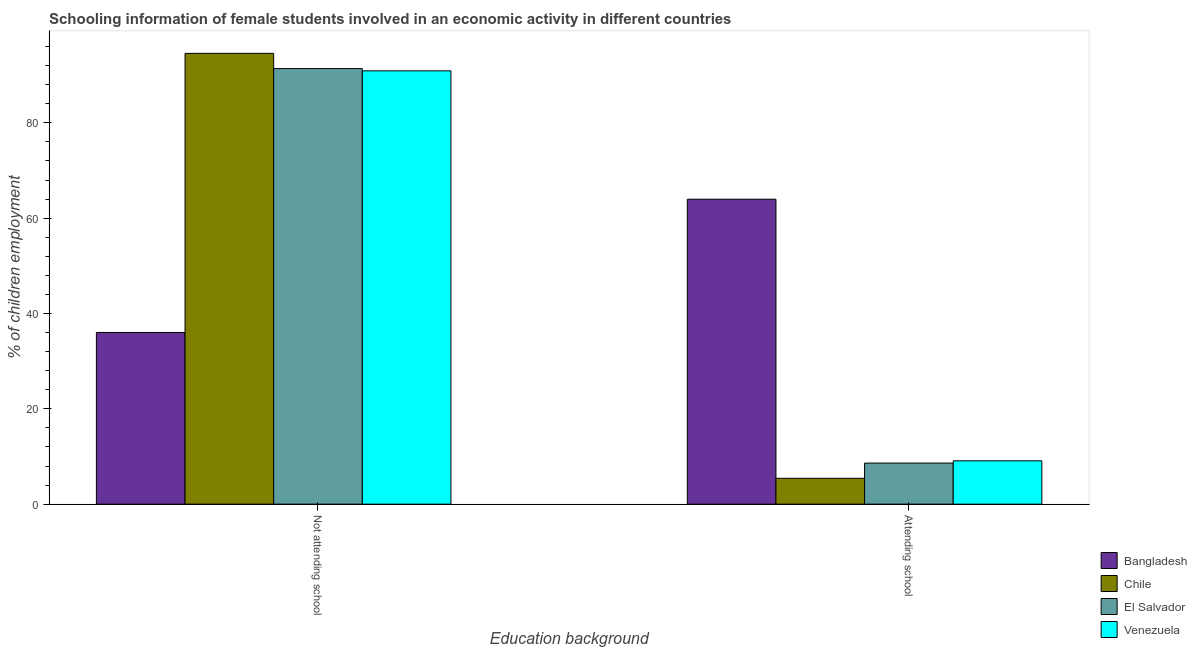How many groups of bars are there?
Make the answer very short. 2. Are the number of bars on each tick of the X-axis equal?
Your answer should be very brief. Yes. What is the label of the 1st group of bars from the left?
Your answer should be very brief. Not attending school. What is the percentage of employed females who are not attending school in Chile?
Your answer should be very brief. 94.57. Across all countries, what is the maximum percentage of employed females who are not attending school?
Provide a succinct answer. 94.57. Across all countries, what is the minimum percentage of employed females who are attending school?
Your answer should be very brief. 5.43. In which country was the percentage of employed females who are not attending school minimum?
Give a very brief answer. Bangladesh. What is the total percentage of employed females who are not attending school in the graph?
Your response must be concise. 312.89. What is the difference between the percentage of employed females who are attending school in Venezuela and that in Chile?
Provide a short and direct response. 3.67. What is the difference between the percentage of employed females who are not attending school in Chile and the percentage of employed females who are attending school in Bangladesh?
Keep it short and to the point. 30.6. What is the average percentage of employed females who are attending school per country?
Make the answer very short. 21.78. What is the difference between the percentage of employed females who are not attending school and percentage of employed females who are attending school in Bangladesh?
Give a very brief answer. -27.95. In how many countries, is the percentage of employed females who are not attending school greater than 32 %?
Your answer should be very brief. 4. What is the ratio of the percentage of employed females who are not attending school in Bangladesh to that in Venezuela?
Provide a short and direct response. 0.4. Is the percentage of employed females who are not attending school in Venezuela less than that in Bangladesh?
Offer a very short reply. No. In how many countries, is the percentage of employed females who are not attending school greater than the average percentage of employed females who are not attending school taken over all countries?
Provide a short and direct response. 3. What does the 2nd bar from the left in Attending school represents?
Your answer should be compact. Chile. What does the 2nd bar from the right in Attending school represents?
Offer a terse response. El Salvador. How many bars are there?
Give a very brief answer. 8. How many countries are there in the graph?
Your response must be concise. 4. Are the values on the major ticks of Y-axis written in scientific E-notation?
Provide a short and direct response. No. Does the graph contain any zero values?
Your response must be concise. No. Where does the legend appear in the graph?
Give a very brief answer. Bottom right. How are the legend labels stacked?
Provide a succinct answer. Vertical. What is the title of the graph?
Your response must be concise. Schooling information of female students involved in an economic activity in different countries. Does "Botswana" appear as one of the legend labels in the graph?
Provide a succinct answer. No. What is the label or title of the X-axis?
Your answer should be very brief. Education background. What is the label or title of the Y-axis?
Provide a short and direct response. % of children employment. What is the % of children employment of Bangladesh in Not attending school?
Provide a short and direct response. 36.02. What is the % of children employment in Chile in Not attending school?
Offer a terse response. 94.57. What is the % of children employment of El Salvador in Not attending school?
Make the answer very short. 91.38. What is the % of children employment in Venezuela in Not attending school?
Keep it short and to the point. 90.91. What is the % of children employment in Bangladesh in Attending school?
Provide a short and direct response. 63.98. What is the % of children employment in Chile in Attending school?
Your answer should be very brief. 5.43. What is the % of children employment in El Salvador in Attending school?
Provide a succinct answer. 8.62. What is the % of children employment of Venezuela in Attending school?
Offer a very short reply. 9.09. Across all Education background, what is the maximum % of children employment in Bangladesh?
Ensure brevity in your answer.  63.98. Across all Education background, what is the maximum % of children employment of Chile?
Ensure brevity in your answer.  94.57. Across all Education background, what is the maximum % of children employment in El Salvador?
Provide a short and direct response. 91.38. Across all Education background, what is the maximum % of children employment of Venezuela?
Keep it short and to the point. 90.91. Across all Education background, what is the minimum % of children employment of Bangladesh?
Offer a terse response. 36.02. Across all Education background, what is the minimum % of children employment of Chile?
Your answer should be compact. 5.43. Across all Education background, what is the minimum % of children employment in El Salvador?
Your answer should be very brief. 8.62. Across all Education background, what is the minimum % of children employment of Venezuela?
Keep it short and to the point. 9.09. What is the total % of children employment of Chile in the graph?
Your answer should be compact. 100. What is the total % of children employment in El Salvador in the graph?
Your answer should be compact. 100. What is the difference between the % of children employment of Bangladesh in Not attending school and that in Attending school?
Keep it short and to the point. -27.95. What is the difference between the % of children employment in Chile in Not attending school and that in Attending school?
Make the answer very short. 89.15. What is the difference between the % of children employment of El Salvador in Not attending school and that in Attending school?
Your answer should be compact. 82.77. What is the difference between the % of children employment in Venezuela in Not attending school and that in Attending school?
Ensure brevity in your answer.  81.82. What is the difference between the % of children employment in Bangladesh in Not attending school and the % of children employment in Chile in Attending school?
Provide a short and direct response. 30.6. What is the difference between the % of children employment in Bangladesh in Not attending school and the % of children employment in El Salvador in Attending school?
Offer a very short reply. 27.41. What is the difference between the % of children employment in Bangladesh in Not attending school and the % of children employment in Venezuela in Attending school?
Ensure brevity in your answer.  26.93. What is the difference between the % of children employment in Chile in Not attending school and the % of children employment in El Salvador in Attending school?
Ensure brevity in your answer.  85.96. What is the difference between the % of children employment in Chile in Not attending school and the % of children employment in Venezuela in Attending school?
Provide a short and direct response. 85.48. What is the difference between the % of children employment in El Salvador in Not attending school and the % of children employment in Venezuela in Attending school?
Provide a short and direct response. 82.29. What is the average % of children employment in Chile per Education background?
Offer a terse response. 50. What is the average % of children employment in El Salvador per Education background?
Provide a succinct answer. 50. What is the average % of children employment of Venezuela per Education background?
Make the answer very short. 50. What is the difference between the % of children employment of Bangladesh and % of children employment of Chile in Not attending school?
Make the answer very short. -58.55. What is the difference between the % of children employment in Bangladesh and % of children employment in El Salvador in Not attending school?
Your answer should be compact. -55.36. What is the difference between the % of children employment in Bangladesh and % of children employment in Venezuela in Not attending school?
Ensure brevity in your answer.  -54.88. What is the difference between the % of children employment in Chile and % of children employment in El Salvador in Not attending school?
Provide a succinct answer. 3.19. What is the difference between the % of children employment in Chile and % of children employment in Venezuela in Not attending school?
Ensure brevity in your answer.  3.67. What is the difference between the % of children employment of El Salvador and % of children employment of Venezuela in Not attending school?
Your answer should be very brief. 0.47. What is the difference between the % of children employment of Bangladesh and % of children employment of Chile in Attending school?
Provide a short and direct response. 58.55. What is the difference between the % of children employment of Bangladesh and % of children employment of El Salvador in Attending school?
Provide a short and direct response. 55.36. What is the difference between the % of children employment in Bangladesh and % of children employment in Venezuela in Attending school?
Your answer should be very brief. 54.88. What is the difference between the % of children employment of Chile and % of children employment of El Salvador in Attending school?
Provide a succinct answer. -3.19. What is the difference between the % of children employment of Chile and % of children employment of Venezuela in Attending school?
Keep it short and to the point. -3.67. What is the difference between the % of children employment of El Salvador and % of children employment of Venezuela in Attending school?
Your answer should be compact. -0.47. What is the ratio of the % of children employment of Bangladesh in Not attending school to that in Attending school?
Offer a terse response. 0.56. What is the ratio of the % of children employment in Chile in Not attending school to that in Attending school?
Your response must be concise. 17.43. What is the ratio of the % of children employment in El Salvador in Not attending school to that in Attending school?
Provide a short and direct response. 10.6. What is the difference between the highest and the second highest % of children employment of Bangladesh?
Your answer should be compact. 27.95. What is the difference between the highest and the second highest % of children employment in Chile?
Your response must be concise. 89.15. What is the difference between the highest and the second highest % of children employment of El Salvador?
Give a very brief answer. 82.77. What is the difference between the highest and the second highest % of children employment of Venezuela?
Make the answer very short. 81.82. What is the difference between the highest and the lowest % of children employment in Bangladesh?
Keep it short and to the point. 27.95. What is the difference between the highest and the lowest % of children employment in Chile?
Ensure brevity in your answer.  89.15. What is the difference between the highest and the lowest % of children employment in El Salvador?
Make the answer very short. 82.77. What is the difference between the highest and the lowest % of children employment in Venezuela?
Offer a terse response. 81.82. 